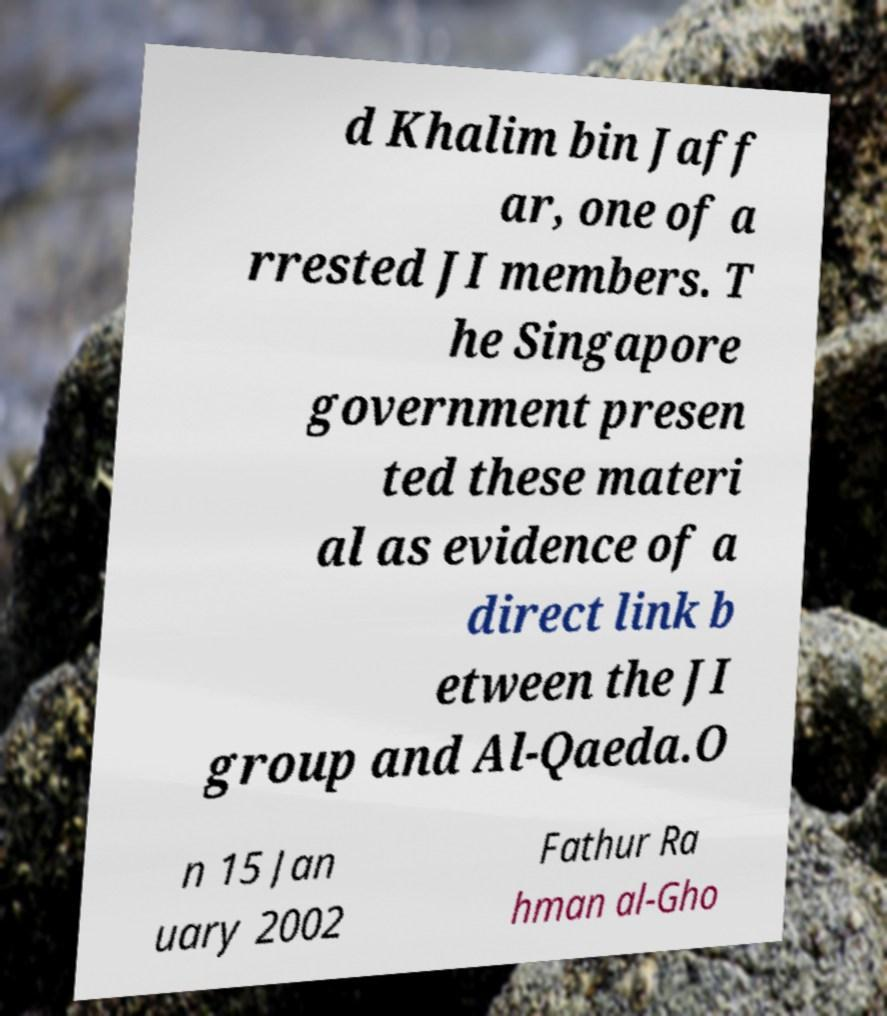Please identify and transcribe the text found in this image. d Khalim bin Jaff ar, one of a rrested JI members. T he Singapore government presen ted these materi al as evidence of a direct link b etween the JI group and Al-Qaeda.O n 15 Jan uary 2002 Fathur Ra hman al-Gho 